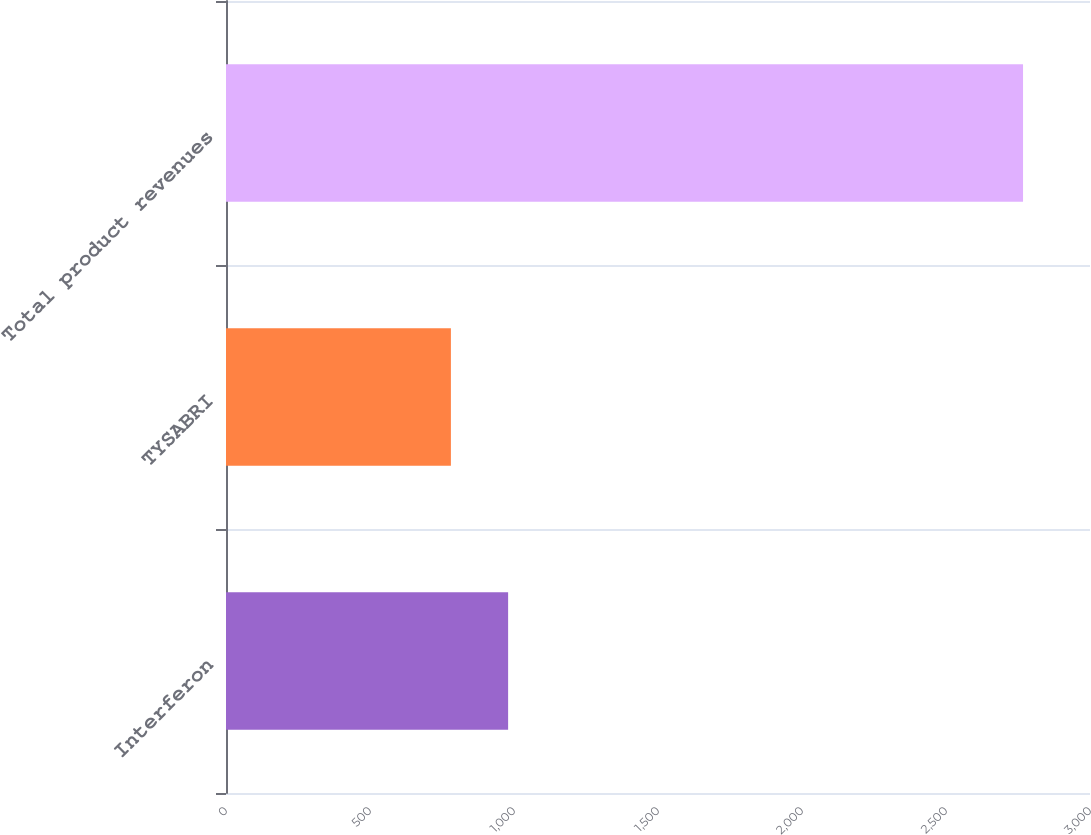Convert chart. <chart><loc_0><loc_0><loc_500><loc_500><bar_chart><fcel>Interferon<fcel>TYSABRI<fcel>Total product revenues<nl><fcel>979.56<fcel>780.9<fcel>2767.5<nl></chart> 